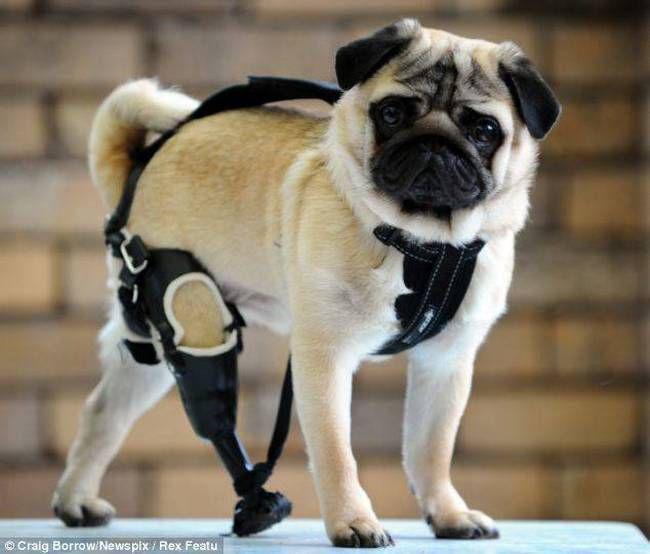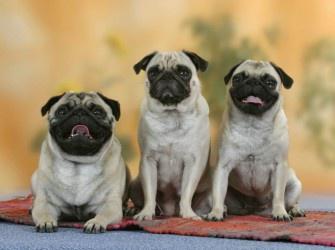The first image is the image on the left, the second image is the image on the right. Assess this claim about the two images: "The right image contains exactly three pug dogs.". Correct or not? Answer yes or no. Yes. The first image is the image on the left, the second image is the image on the right. Considering the images on both sides, is "There are at most two dogs." valid? Answer yes or no. No. 